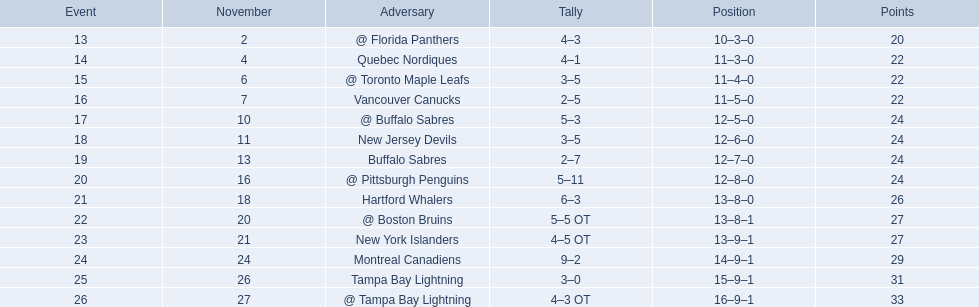Who are all of the teams? @ Florida Panthers, Quebec Nordiques, @ Toronto Maple Leafs, Vancouver Canucks, @ Buffalo Sabres, New Jersey Devils, Buffalo Sabres, @ Pittsburgh Penguins, Hartford Whalers, @ Boston Bruins, New York Islanders, Montreal Canadiens, Tampa Bay Lightning. What games finished in overtime? 22, 23, 26. In game number 23, who did they face? New York Islanders. 